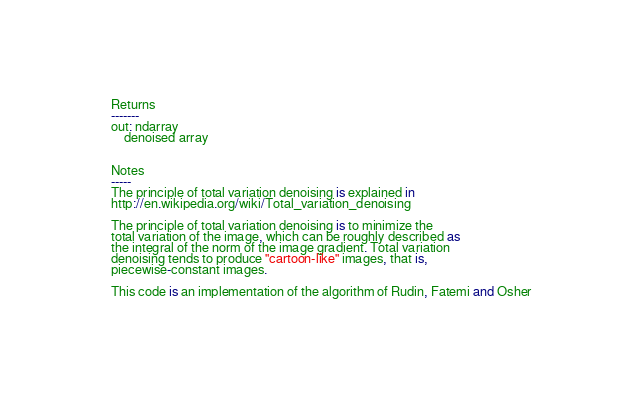<code> <loc_0><loc_0><loc_500><loc_500><_Python_>
    Returns
    -------
    out: ndarray
        denoised array


    Notes
    -----
    The principle of total variation denoising is explained in
    http://en.wikipedia.org/wiki/Total_variation_denoising

    The principle of total variation denoising is to minimize the
    total variation of the image, which can be roughly described as
    the integral of the norm of the image gradient. Total variation
    denoising tends to produce "cartoon-like" images, that is,
    piecewise-constant images.

    This code is an implementation of the algorithm of Rudin, Fatemi and Osher</code> 